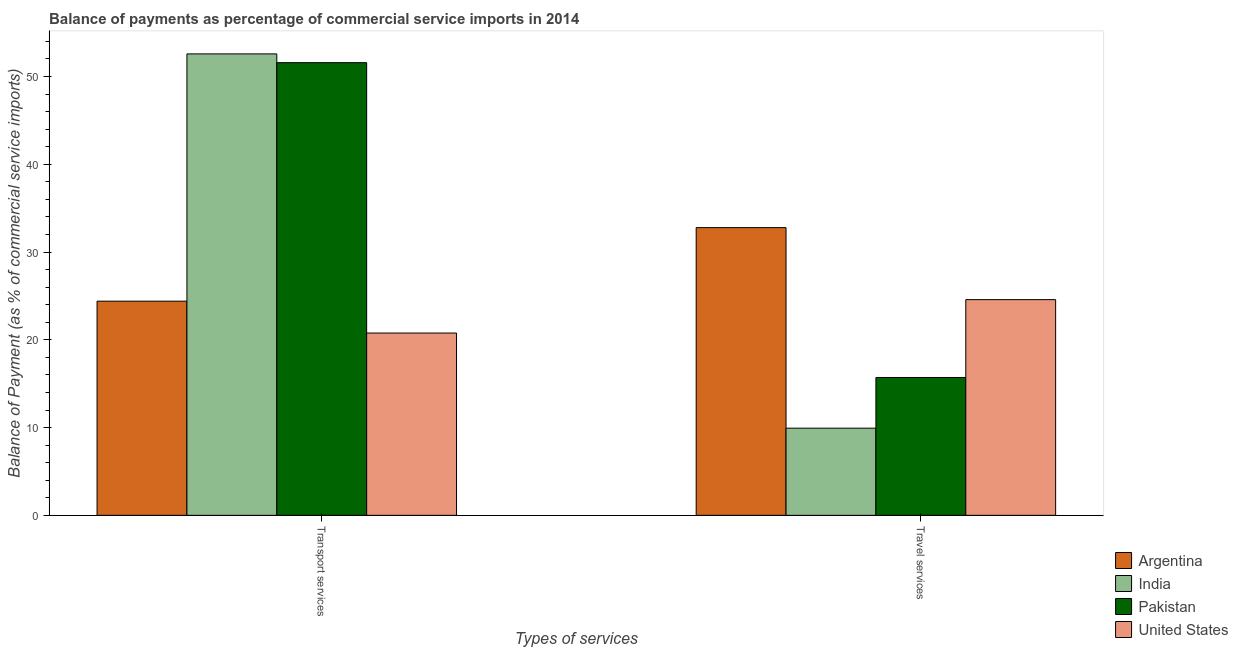Are the number of bars per tick equal to the number of legend labels?
Make the answer very short. Yes. How many bars are there on the 2nd tick from the left?
Your answer should be very brief. 4. What is the label of the 2nd group of bars from the left?
Ensure brevity in your answer.  Travel services. What is the balance of payments of travel services in Argentina?
Provide a short and direct response. 32.79. Across all countries, what is the maximum balance of payments of travel services?
Give a very brief answer. 32.79. Across all countries, what is the minimum balance of payments of travel services?
Keep it short and to the point. 9.93. In which country was the balance of payments of travel services maximum?
Ensure brevity in your answer.  Argentina. What is the total balance of payments of travel services in the graph?
Keep it short and to the point. 83.01. What is the difference between the balance of payments of transport services in Argentina and that in Pakistan?
Offer a terse response. -27.18. What is the difference between the balance of payments of travel services in India and the balance of payments of transport services in Pakistan?
Provide a short and direct response. -41.65. What is the average balance of payments of transport services per country?
Offer a very short reply. 37.33. What is the difference between the balance of payments of transport services and balance of payments of travel services in Argentina?
Your answer should be compact. -8.38. What is the ratio of the balance of payments of travel services in Argentina to that in United States?
Offer a very short reply. 1.33. Is the balance of payments of travel services in United States less than that in India?
Your answer should be compact. No. Are all the bars in the graph horizontal?
Make the answer very short. No. How many countries are there in the graph?
Your response must be concise. 4. Does the graph contain grids?
Your response must be concise. No. What is the title of the graph?
Your response must be concise. Balance of payments as percentage of commercial service imports in 2014. What is the label or title of the X-axis?
Provide a short and direct response. Types of services. What is the label or title of the Y-axis?
Offer a terse response. Balance of Payment (as % of commercial service imports). What is the Balance of Payment (as % of commercial service imports) of Argentina in Transport services?
Your answer should be compact. 24.4. What is the Balance of Payment (as % of commercial service imports) of India in Transport services?
Your response must be concise. 52.58. What is the Balance of Payment (as % of commercial service imports) in Pakistan in Transport services?
Offer a very short reply. 51.58. What is the Balance of Payment (as % of commercial service imports) of United States in Transport services?
Ensure brevity in your answer.  20.77. What is the Balance of Payment (as % of commercial service imports) of Argentina in Travel services?
Ensure brevity in your answer.  32.79. What is the Balance of Payment (as % of commercial service imports) in India in Travel services?
Provide a succinct answer. 9.93. What is the Balance of Payment (as % of commercial service imports) in Pakistan in Travel services?
Offer a very short reply. 15.71. What is the Balance of Payment (as % of commercial service imports) in United States in Travel services?
Offer a very short reply. 24.58. Across all Types of services, what is the maximum Balance of Payment (as % of commercial service imports) of Argentina?
Your answer should be very brief. 32.79. Across all Types of services, what is the maximum Balance of Payment (as % of commercial service imports) of India?
Offer a terse response. 52.58. Across all Types of services, what is the maximum Balance of Payment (as % of commercial service imports) in Pakistan?
Offer a very short reply. 51.58. Across all Types of services, what is the maximum Balance of Payment (as % of commercial service imports) in United States?
Keep it short and to the point. 24.58. Across all Types of services, what is the minimum Balance of Payment (as % of commercial service imports) in Argentina?
Provide a short and direct response. 24.4. Across all Types of services, what is the minimum Balance of Payment (as % of commercial service imports) of India?
Offer a terse response. 9.93. Across all Types of services, what is the minimum Balance of Payment (as % of commercial service imports) in Pakistan?
Your answer should be very brief. 15.71. Across all Types of services, what is the minimum Balance of Payment (as % of commercial service imports) of United States?
Keep it short and to the point. 20.77. What is the total Balance of Payment (as % of commercial service imports) of Argentina in the graph?
Ensure brevity in your answer.  57.19. What is the total Balance of Payment (as % of commercial service imports) of India in the graph?
Offer a very short reply. 62.51. What is the total Balance of Payment (as % of commercial service imports) in Pakistan in the graph?
Keep it short and to the point. 67.29. What is the total Balance of Payment (as % of commercial service imports) of United States in the graph?
Offer a very short reply. 45.35. What is the difference between the Balance of Payment (as % of commercial service imports) in Argentina in Transport services and that in Travel services?
Your response must be concise. -8.38. What is the difference between the Balance of Payment (as % of commercial service imports) of India in Transport services and that in Travel services?
Give a very brief answer. 42.65. What is the difference between the Balance of Payment (as % of commercial service imports) of Pakistan in Transport services and that in Travel services?
Your answer should be compact. 35.87. What is the difference between the Balance of Payment (as % of commercial service imports) of United States in Transport services and that in Travel services?
Give a very brief answer. -3.81. What is the difference between the Balance of Payment (as % of commercial service imports) in Argentina in Transport services and the Balance of Payment (as % of commercial service imports) in India in Travel services?
Provide a succinct answer. 14.47. What is the difference between the Balance of Payment (as % of commercial service imports) in Argentina in Transport services and the Balance of Payment (as % of commercial service imports) in Pakistan in Travel services?
Offer a terse response. 8.7. What is the difference between the Balance of Payment (as % of commercial service imports) of Argentina in Transport services and the Balance of Payment (as % of commercial service imports) of United States in Travel services?
Offer a very short reply. -0.17. What is the difference between the Balance of Payment (as % of commercial service imports) in India in Transport services and the Balance of Payment (as % of commercial service imports) in Pakistan in Travel services?
Provide a succinct answer. 36.87. What is the difference between the Balance of Payment (as % of commercial service imports) in India in Transport services and the Balance of Payment (as % of commercial service imports) in United States in Travel services?
Provide a succinct answer. 28. What is the difference between the Balance of Payment (as % of commercial service imports) in Pakistan in Transport services and the Balance of Payment (as % of commercial service imports) in United States in Travel services?
Make the answer very short. 27. What is the average Balance of Payment (as % of commercial service imports) in Argentina per Types of services?
Your response must be concise. 28.6. What is the average Balance of Payment (as % of commercial service imports) of India per Types of services?
Give a very brief answer. 31.26. What is the average Balance of Payment (as % of commercial service imports) in Pakistan per Types of services?
Your answer should be very brief. 33.65. What is the average Balance of Payment (as % of commercial service imports) in United States per Types of services?
Offer a very short reply. 22.68. What is the difference between the Balance of Payment (as % of commercial service imports) in Argentina and Balance of Payment (as % of commercial service imports) in India in Transport services?
Offer a very short reply. -28.18. What is the difference between the Balance of Payment (as % of commercial service imports) in Argentina and Balance of Payment (as % of commercial service imports) in Pakistan in Transport services?
Your answer should be very brief. -27.18. What is the difference between the Balance of Payment (as % of commercial service imports) of Argentina and Balance of Payment (as % of commercial service imports) of United States in Transport services?
Make the answer very short. 3.63. What is the difference between the Balance of Payment (as % of commercial service imports) in India and Balance of Payment (as % of commercial service imports) in United States in Transport services?
Give a very brief answer. 31.81. What is the difference between the Balance of Payment (as % of commercial service imports) of Pakistan and Balance of Payment (as % of commercial service imports) of United States in Transport services?
Offer a very short reply. 30.81. What is the difference between the Balance of Payment (as % of commercial service imports) of Argentina and Balance of Payment (as % of commercial service imports) of India in Travel services?
Your answer should be very brief. 22.85. What is the difference between the Balance of Payment (as % of commercial service imports) of Argentina and Balance of Payment (as % of commercial service imports) of Pakistan in Travel services?
Keep it short and to the point. 17.08. What is the difference between the Balance of Payment (as % of commercial service imports) of Argentina and Balance of Payment (as % of commercial service imports) of United States in Travel services?
Offer a terse response. 8.21. What is the difference between the Balance of Payment (as % of commercial service imports) in India and Balance of Payment (as % of commercial service imports) in Pakistan in Travel services?
Keep it short and to the point. -5.78. What is the difference between the Balance of Payment (as % of commercial service imports) of India and Balance of Payment (as % of commercial service imports) of United States in Travel services?
Ensure brevity in your answer.  -14.65. What is the difference between the Balance of Payment (as % of commercial service imports) in Pakistan and Balance of Payment (as % of commercial service imports) in United States in Travel services?
Give a very brief answer. -8.87. What is the ratio of the Balance of Payment (as % of commercial service imports) of Argentina in Transport services to that in Travel services?
Ensure brevity in your answer.  0.74. What is the ratio of the Balance of Payment (as % of commercial service imports) in India in Transport services to that in Travel services?
Keep it short and to the point. 5.29. What is the ratio of the Balance of Payment (as % of commercial service imports) of Pakistan in Transport services to that in Travel services?
Offer a terse response. 3.28. What is the ratio of the Balance of Payment (as % of commercial service imports) of United States in Transport services to that in Travel services?
Keep it short and to the point. 0.85. What is the difference between the highest and the second highest Balance of Payment (as % of commercial service imports) in Argentina?
Offer a very short reply. 8.38. What is the difference between the highest and the second highest Balance of Payment (as % of commercial service imports) of India?
Ensure brevity in your answer.  42.65. What is the difference between the highest and the second highest Balance of Payment (as % of commercial service imports) in Pakistan?
Offer a terse response. 35.87. What is the difference between the highest and the second highest Balance of Payment (as % of commercial service imports) in United States?
Provide a short and direct response. 3.81. What is the difference between the highest and the lowest Balance of Payment (as % of commercial service imports) of Argentina?
Your answer should be compact. 8.38. What is the difference between the highest and the lowest Balance of Payment (as % of commercial service imports) in India?
Keep it short and to the point. 42.65. What is the difference between the highest and the lowest Balance of Payment (as % of commercial service imports) of Pakistan?
Keep it short and to the point. 35.87. What is the difference between the highest and the lowest Balance of Payment (as % of commercial service imports) in United States?
Offer a terse response. 3.81. 